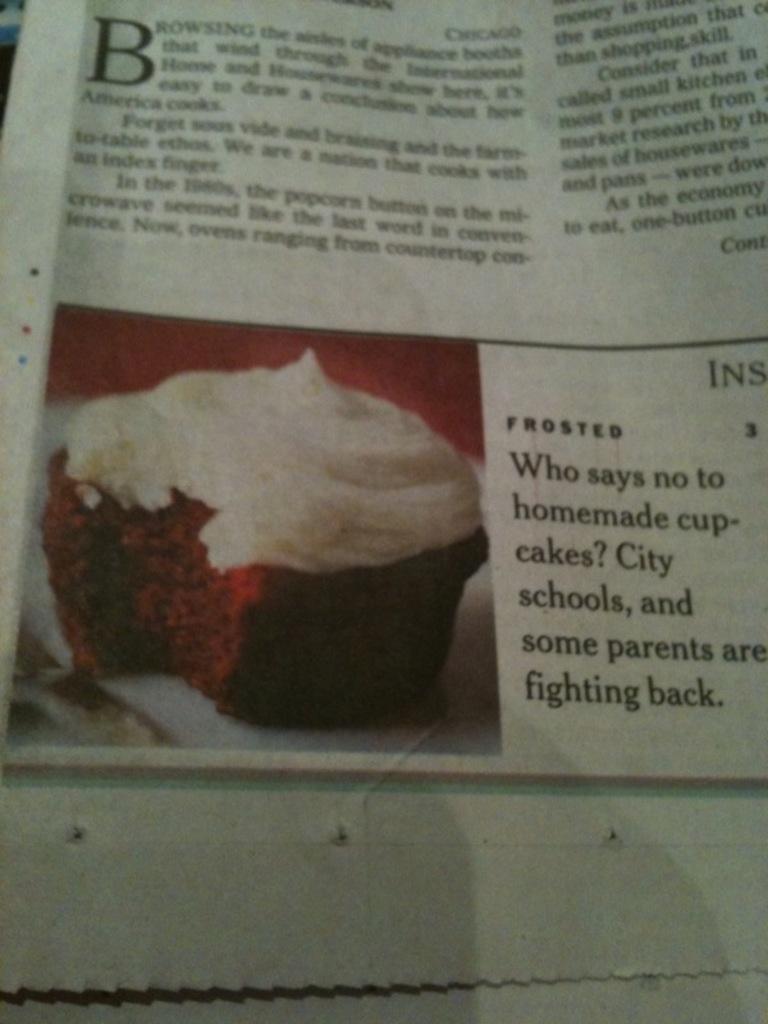What is the letter in bold at the top?
Ensure brevity in your answer.  B. 